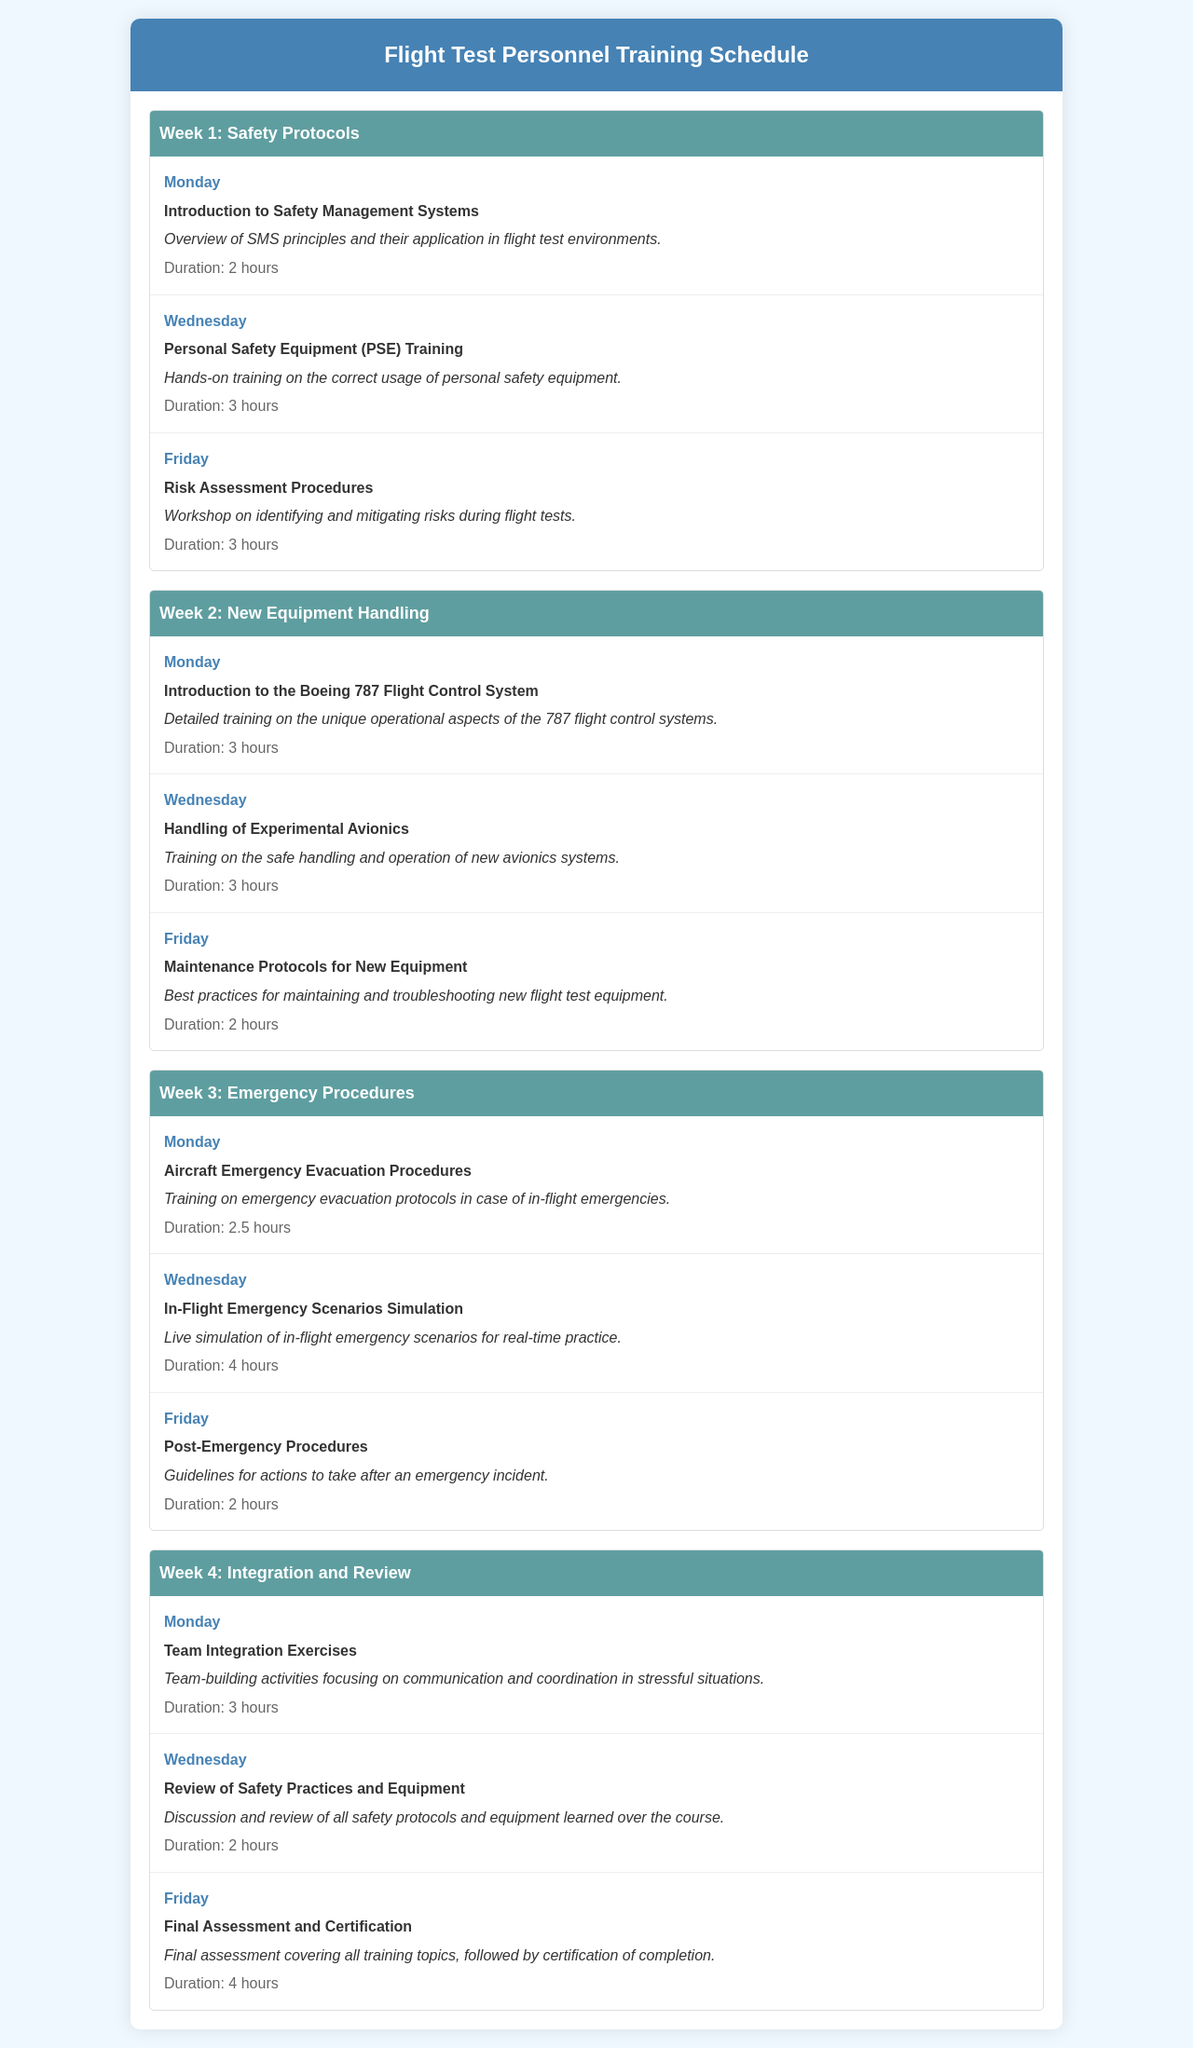What is the first training topic in Week 1? The first training topic in Week 1 is the "Introduction to Safety Management Systems."
Answer: Introduction to Safety Management Systems How long is the session on "In-Flight Emergency Scenarios Simulation"? The duration for the session on "In-Flight Emergency Scenarios Simulation" is found in its description, which states it is 4 hours long.
Answer: 4 hours On which day does the "Post-Emergency Procedures" training occur? This training takes place on Friday of Week 3, as indicated in the schedule.
Answer: Friday What type of training is provided on Wednesday of Week 2? The training on Wednesday of Week 2 is about the "Handling of Experimental Avionics," which is specified in the document.
Answer: Handling of Experimental Avionics How many total hours does the "Final Assessment and Certification" last? The document specifies that this session lasts 4 hours in total, making it easy to retrieve this information.
Answer: 4 hours Which week focuses on Emergency Procedures? The document states that Week 3 is dedicated to Emergency Procedures, making this question straightforward to answer.
Answer: Week 3 What session is held on Monday of Week 4? The session on Monday of Week 4 is "Team Integration Exercises," as per the schedule's listing.
Answer: Team Integration Exercises How many sessions are there in Week 1? The document lists three sessions for Week 1, thus making it easy to count them directly.
Answer: 3 sessions 